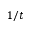<formula> <loc_0><loc_0><loc_500><loc_500>1 / t</formula> 